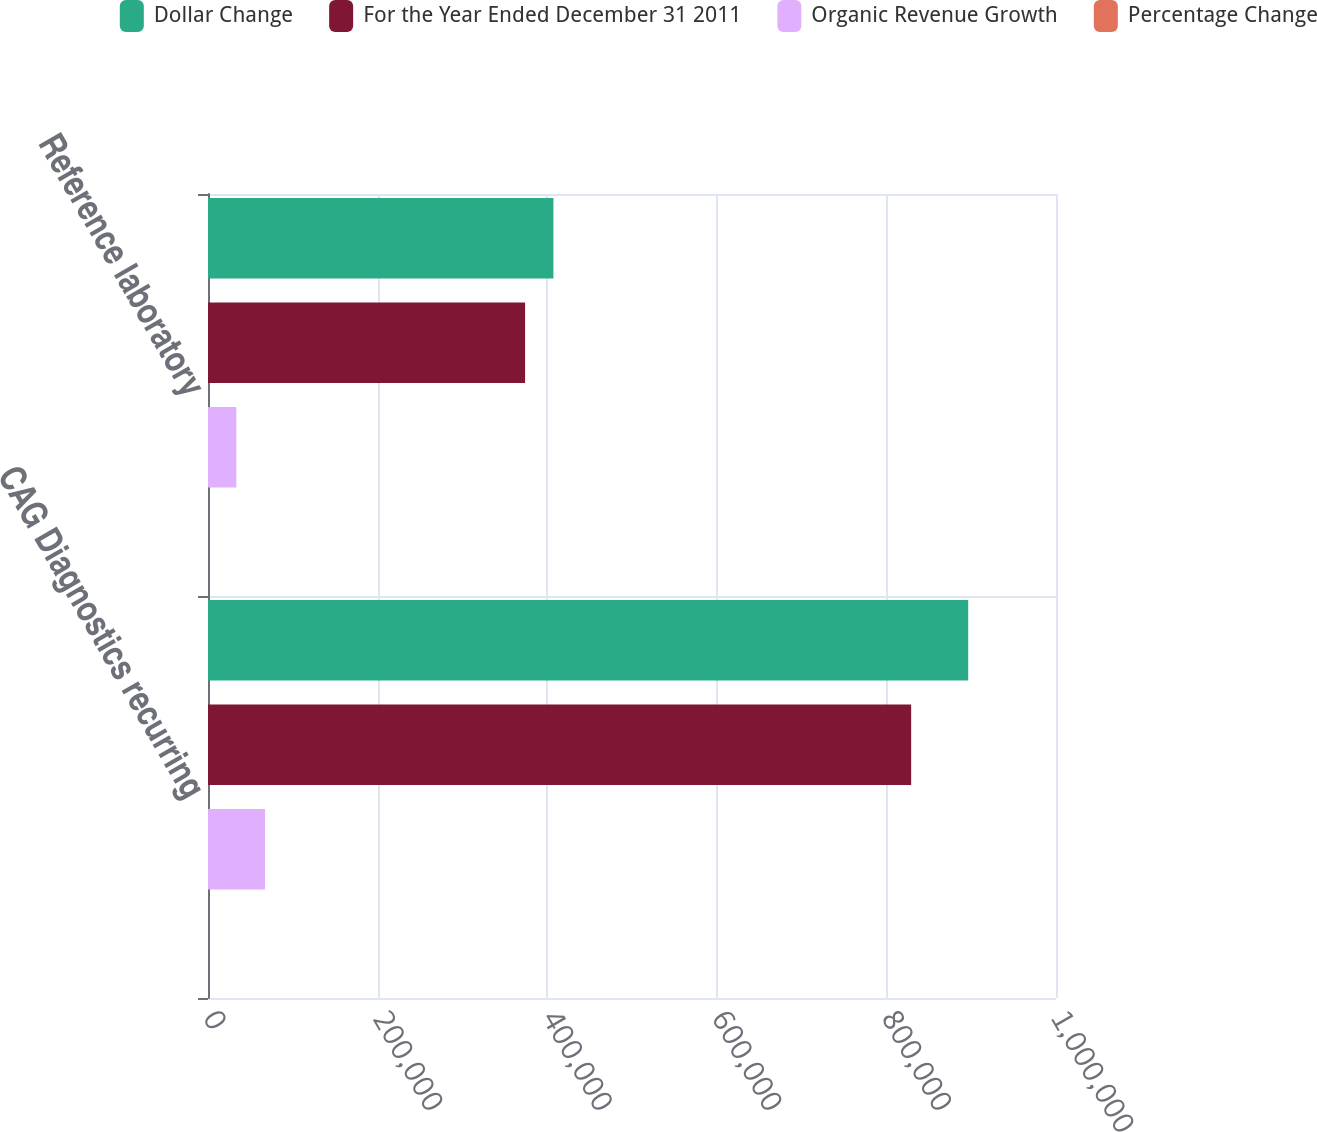Convert chart to OTSL. <chart><loc_0><loc_0><loc_500><loc_500><stacked_bar_chart><ecel><fcel>CAG Diagnostics recurring<fcel>Reference laboratory<nl><fcel>Dollar Change<fcel>896449<fcel>407343<nl><fcel>For the Year Ended December 31 2011<fcel>829192<fcel>373919<nl><fcel>Organic Revenue Growth<fcel>67257<fcel>33424<nl><fcel>Percentage Change<fcel>8.1<fcel>8.9<nl></chart> 